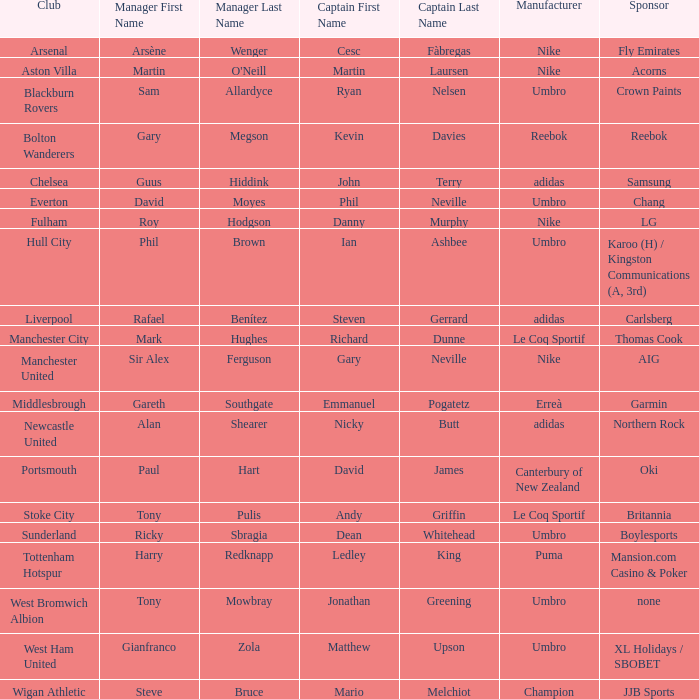Which Manchester United captain is sponsored by Nike? Gary Neville. 